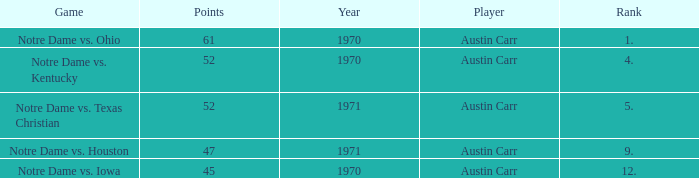Which Rank is the lowest one that has Points larger than 52, and a Year larger than 1970? None. 